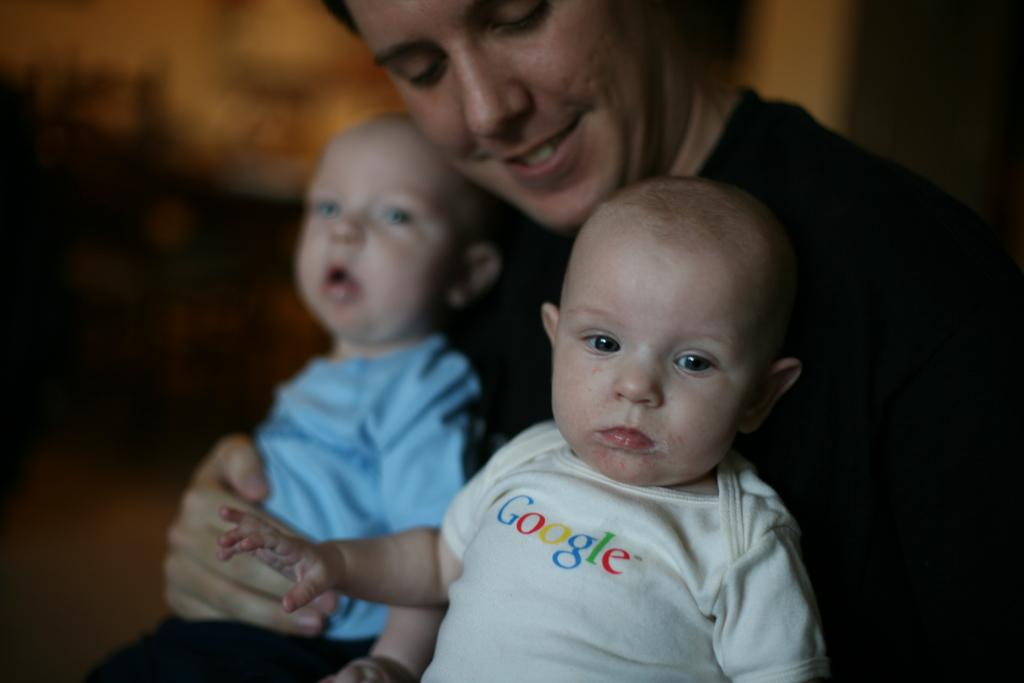What is the person in the image doing? The person is holding two babies. Can you describe the appearance of the babies? One of the babies has something written on their dress. What can be observed about the background of the image? The background of the image is blurred. What type of guitar can be seen being played by the person in the image? There is no guitar present in the image; the person is holding two babies. Can you describe the taste of the sea in the image? There is no sea present in the image, so it is not possible to describe its taste. 